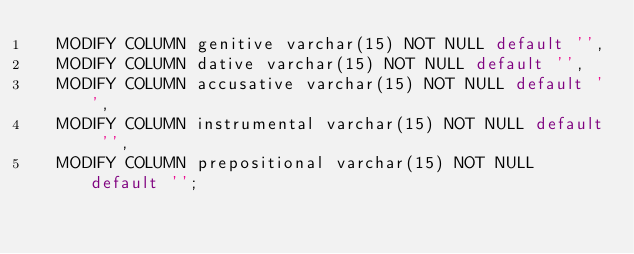Convert code to text. <code><loc_0><loc_0><loc_500><loc_500><_SQL_>  MODIFY COLUMN genitive varchar(15) NOT NULL default '',
  MODIFY COLUMN dative varchar(15) NOT NULL default '',
  MODIFY COLUMN accusative varchar(15) NOT NULL default '',
  MODIFY COLUMN instrumental varchar(15) NOT NULL default '',
  MODIFY COLUMN prepositional varchar(15) NOT NULL default '';
</code> 